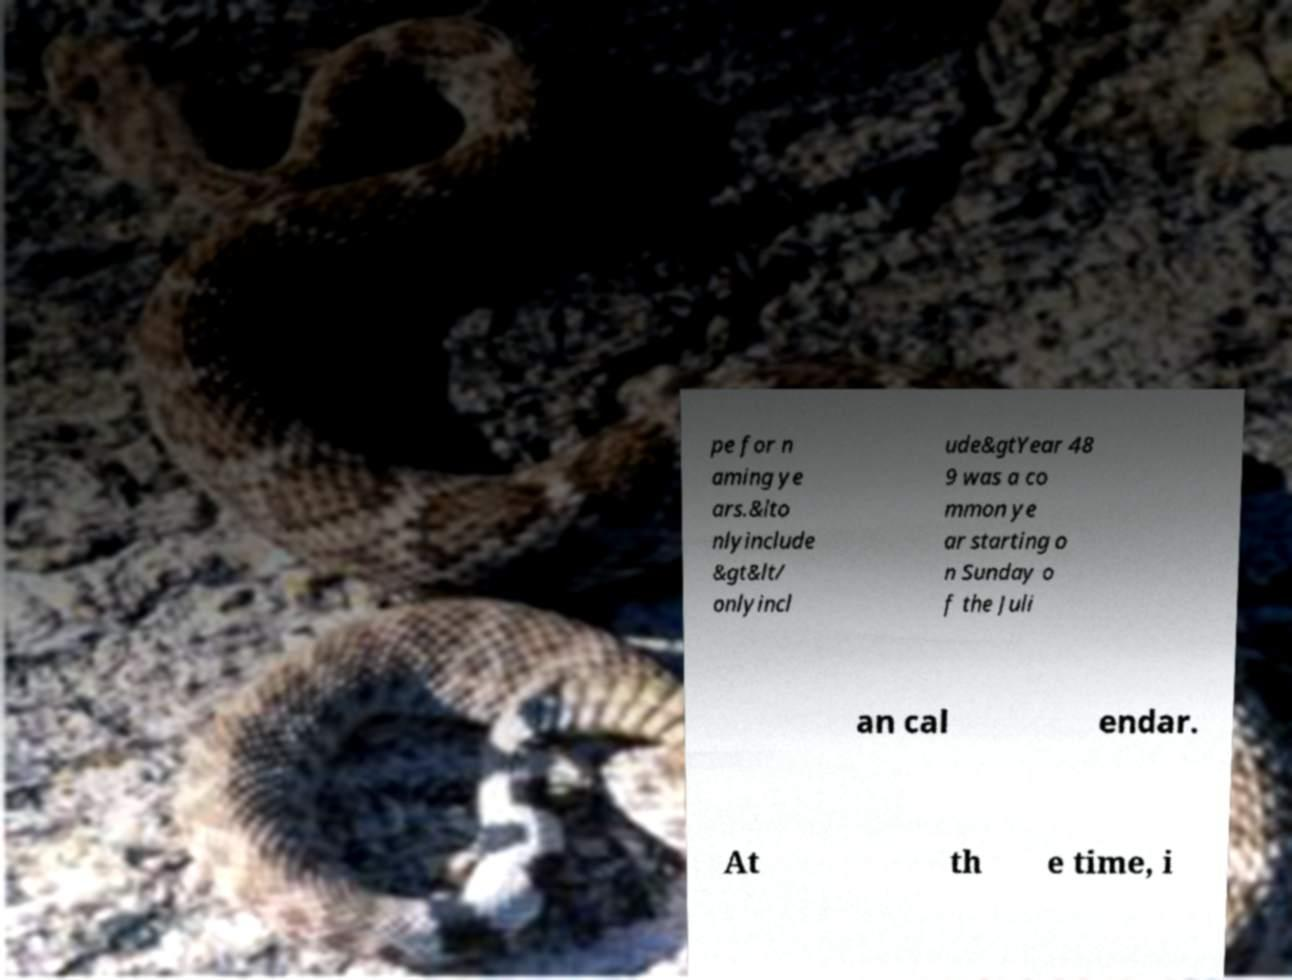For documentation purposes, I need the text within this image transcribed. Could you provide that? pe for n aming ye ars.&lto nlyinclude &gt&lt/ onlyincl ude&gtYear 48 9 was a co mmon ye ar starting o n Sunday o f the Juli an cal endar. At th e time, i 